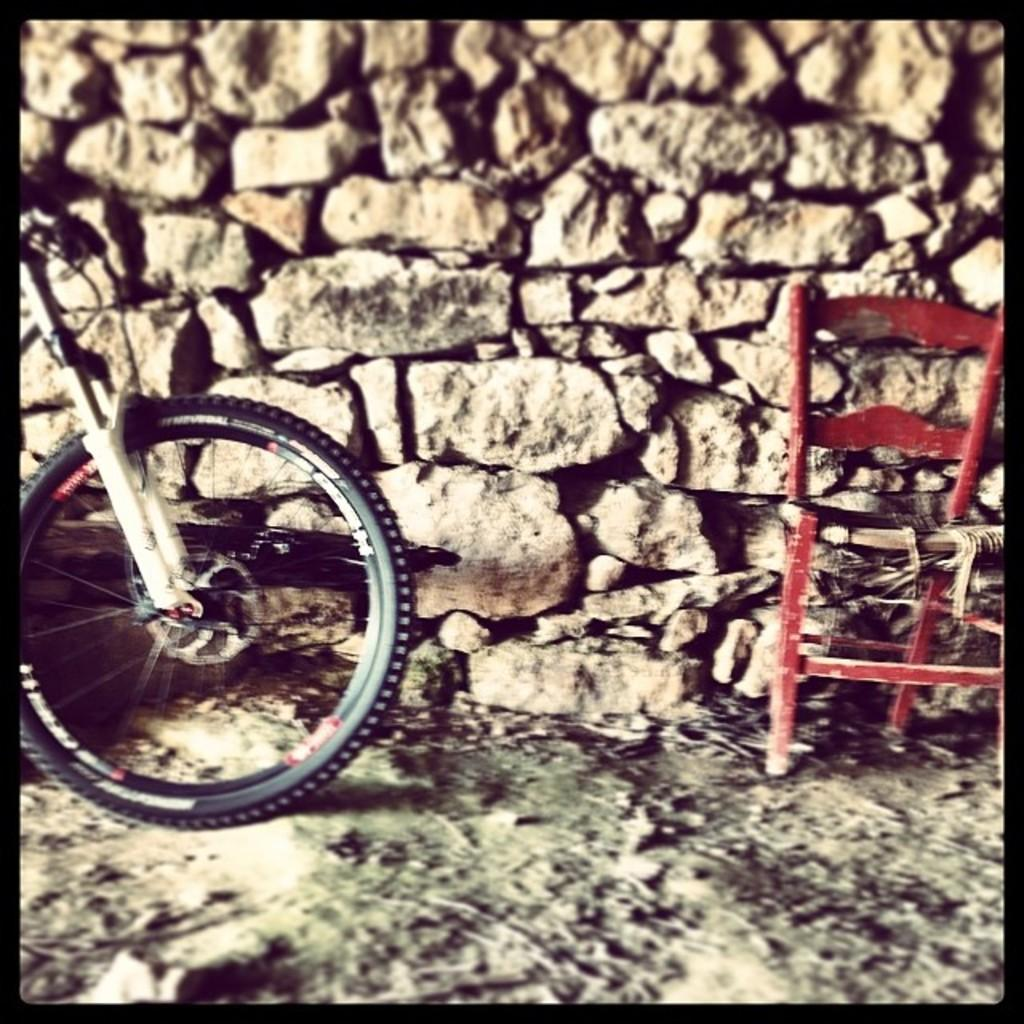What color is the chair that is visible in the image? There is a red chair in the image. Where is the red chair located in relation to other objects in the image? The red chair is placed near a stone wall. What other mode of transportation can be seen in the image? There is a bicycle on the left side of the image. What type of flower is growing near the red chair in the image? There are no flowers visible in the image; it only features a red chair, a stone wall, and a bicycle. 